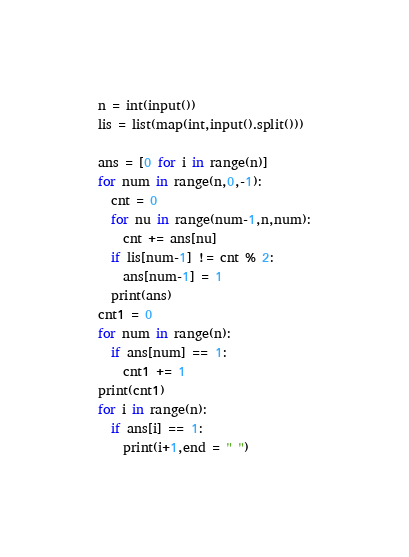Convert code to text. <code><loc_0><loc_0><loc_500><loc_500><_Python_>n = int(input())
lis = list(map(int,input().split()))

ans = [0 for i in range(n)]
for num in range(n,0,-1):
  cnt = 0
  for nu in range(num-1,n,num):
    cnt += ans[nu]
  if lis[num-1] != cnt % 2:
    ans[num-1] = 1
  print(ans)
cnt1 = 0
for num in range(n):
  if ans[num] == 1:
    cnt1 += 1
print(cnt1)
for i in range(n):
  if ans[i] == 1:
    print(i+1,end = " ")</code> 